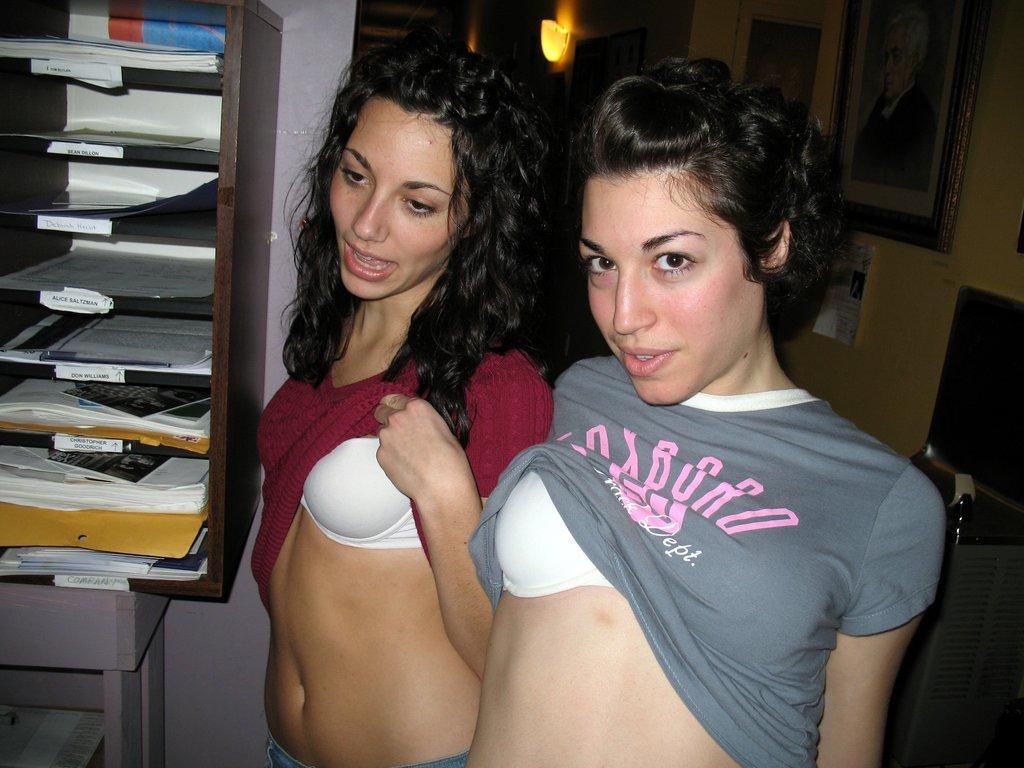<image>
Present a compact description of the photo's key features. Two girls flashing their bras next to Alice Salyzman's inbox. 